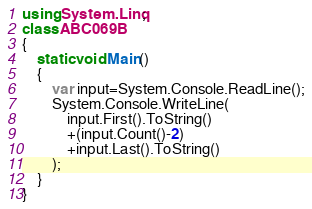<code> <loc_0><loc_0><loc_500><loc_500><_C#_>using System.Linq;
class ABC069B
{
    static void Main()
    {
        var input=System.Console.ReadLine();
        System.Console.WriteLine(
            input.First().ToString()
            +(input.Count()-2)
            +input.Last().ToString()
        );
    }
}</code> 